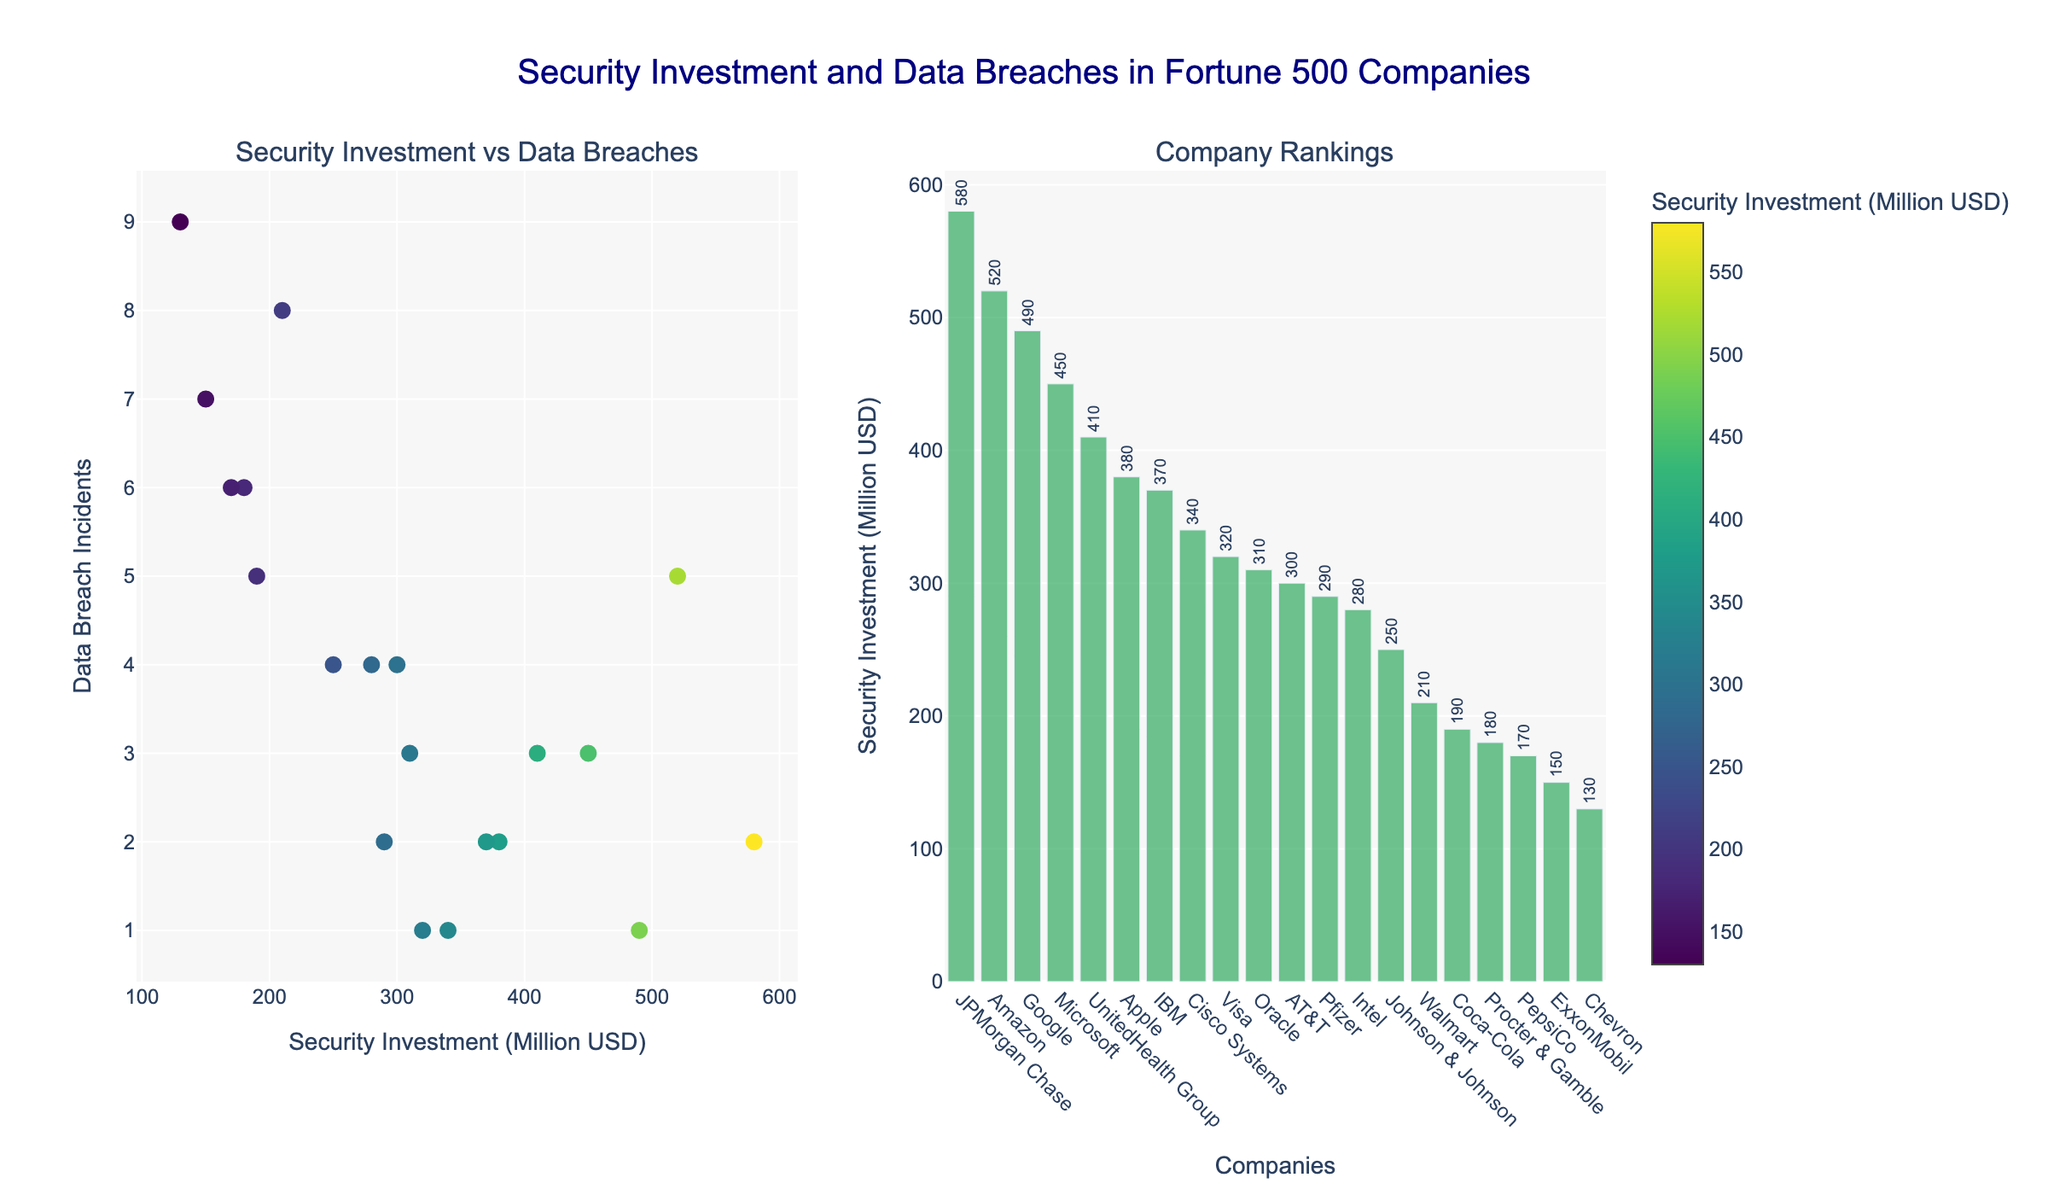What's the title of the figure? The title of the figure is displayed at the top and reads "Security Investment and Data Breaches in Fortune 500 Companies."
Answer: Security Investment and Data Breaches in Fortune 500 Companies Which company has the highest security investment? The company with the highest bar height in the bar plot, indicating the highest security investment, is JPMorgan Chase.
Answer: JPMorgan Chase Which company has the lowest number of data breach incidents? The scatter plot shows that both Google and Visa have the lowest number of data breach incidents, with only 1 incident each, marked by their positions on the y-axis.
Answer: Google and Visa How many million USD does Microsoft invest in security? Referring to the hover information on the scatter plot or by checking the bar height, Microsoft invests 450 million USD in security.
Answer: 450 million USD Compare the security investments of Apple and Amazon. Which is higher and by how much? Apple’s security investment is 380 million USD, and Amazon’s is 520 million USD. The difference is calculated as 520 - 380 = 140 million USD.
Answer: Amazon by 140 million USD What is the total security investment of companies with 2 data breach incidents? The companies with 2 data breach incidents are Apple, JPMorgan Chase, Pfizer, IBM. Their investments are 380, 580, 290, and 370 million USD respectively. Summing these gives 380 + 580 + 290 + 370 = 1620 million USD.
Answer: 1620 million USD Which companies experienced more than 5 data breach incidents? The scatter plot shows Walmart, Procter & Gamble, Chevron, and PepsiCo placed on the y-axis above 5 breach incidents.
Answer: Walmart, Procter & Gamble, Chevron, and PepsiCo What is the median security investment among all companies listed? The sorted security investments in million USD are [130, 150, 170, 180, 190, 210, 250, 280, 290, 300, 310, 320, 340, 370, 380, 410, 450, 490, 520, 580]. The median value (10th and 11th entries) is (290+300)/2 = 295 million USD.
Answer: 295 million USD Is there any visible correlation between security investment and data breach incidents? By examining the scatter plot, one might observe that companies with higher security investments generally have fewer data breach incidents, suggesting a possible inverse correlation.
Answer: Possible inverse correlation 